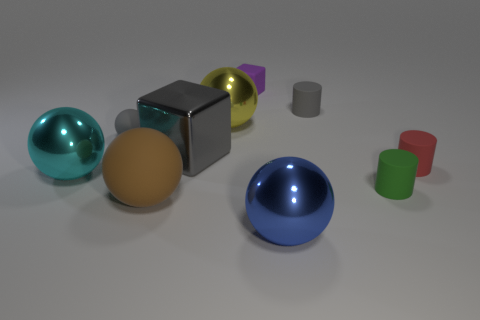Subtract 2 balls. How many balls are left? 3 Subtract all big brown rubber spheres. How many spheres are left? 4 Subtract all blue balls. How many balls are left? 4 Subtract all red balls. Subtract all purple cylinders. How many balls are left? 5 Subtract all cubes. How many objects are left? 8 Add 9 tiny purple cubes. How many tiny purple cubes exist? 10 Subtract 0 blue blocks. How many objects are left? 10 Subtract all tiny brown metallic things. Subtract all blue metallic spheres. How many objects are left? 9 Add 2 big gray metal cubes. How many big gray metal cubes are left? 3 